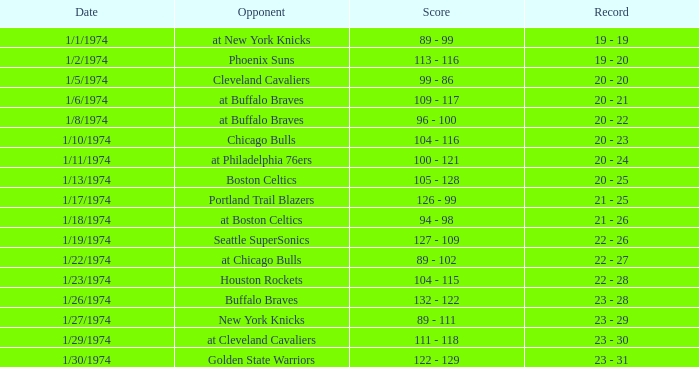What rival participated on 1/13/1974? Boston Celtics. 